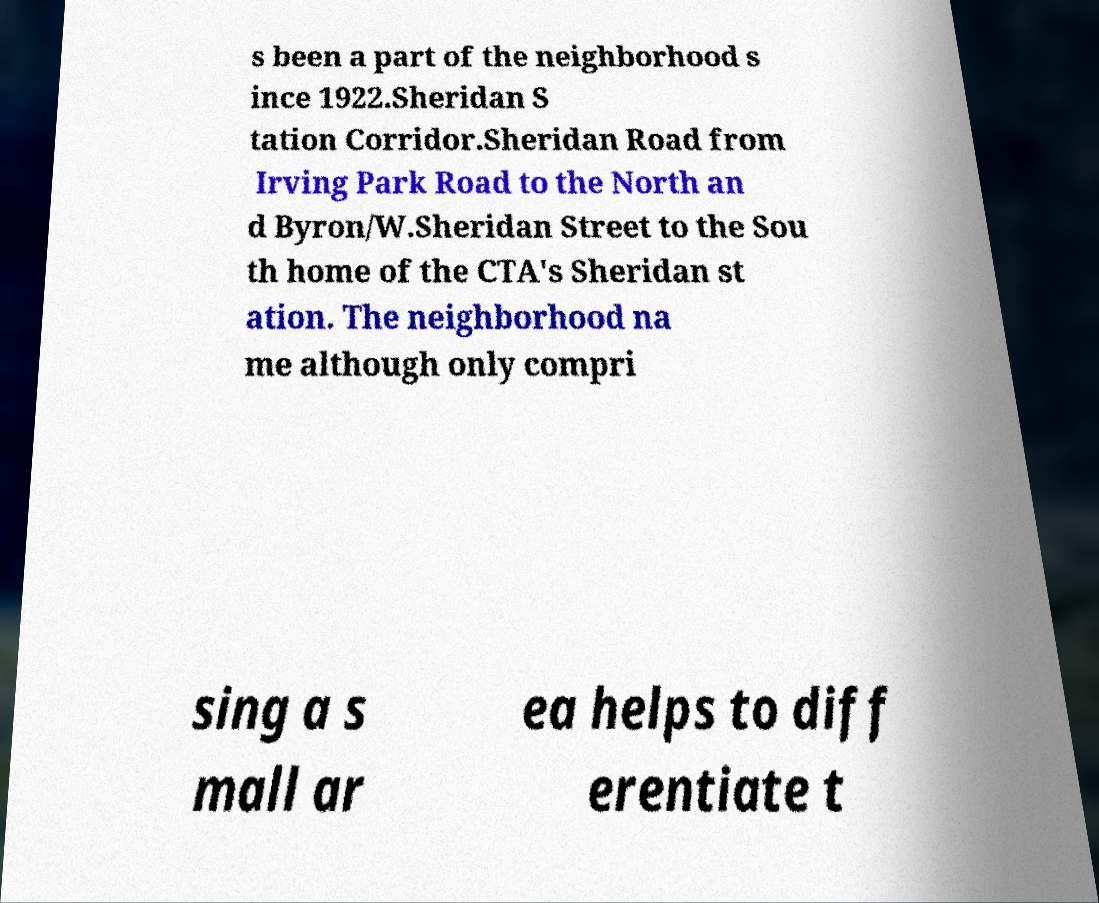There's text embedded in this image that I need extracted. Can you transcribe it verbatim? s been a part of the neighborhood s ince 1922.Sheridan S tation Corridor.Sheridan Road from Irving Park Road to the North an d Byron/W.Sheridan Street to the Sou th home of the CTA's Sheridan st ation. The neighborhood na me although only compri sing a s mall ar ea helps to diff erentiate t 